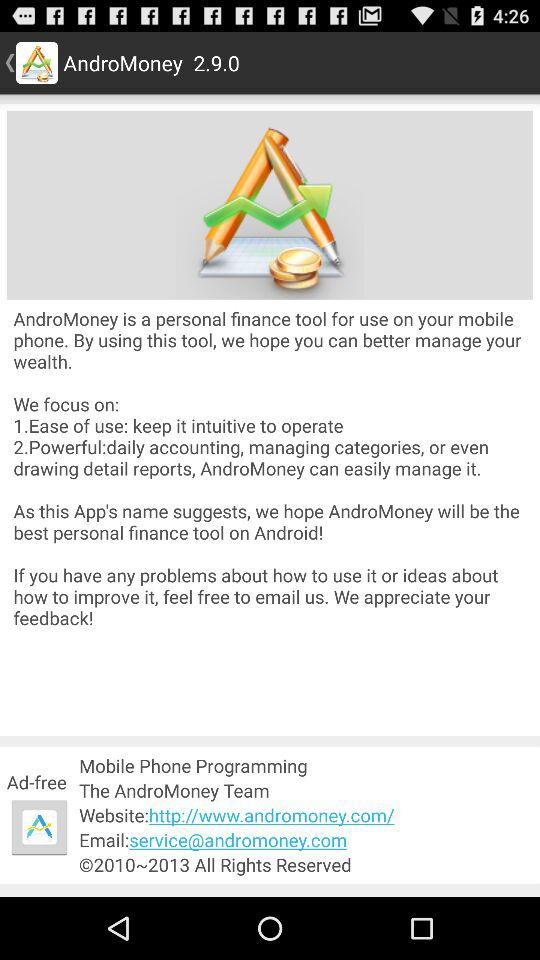What is the version? The version is 2.9.0. 